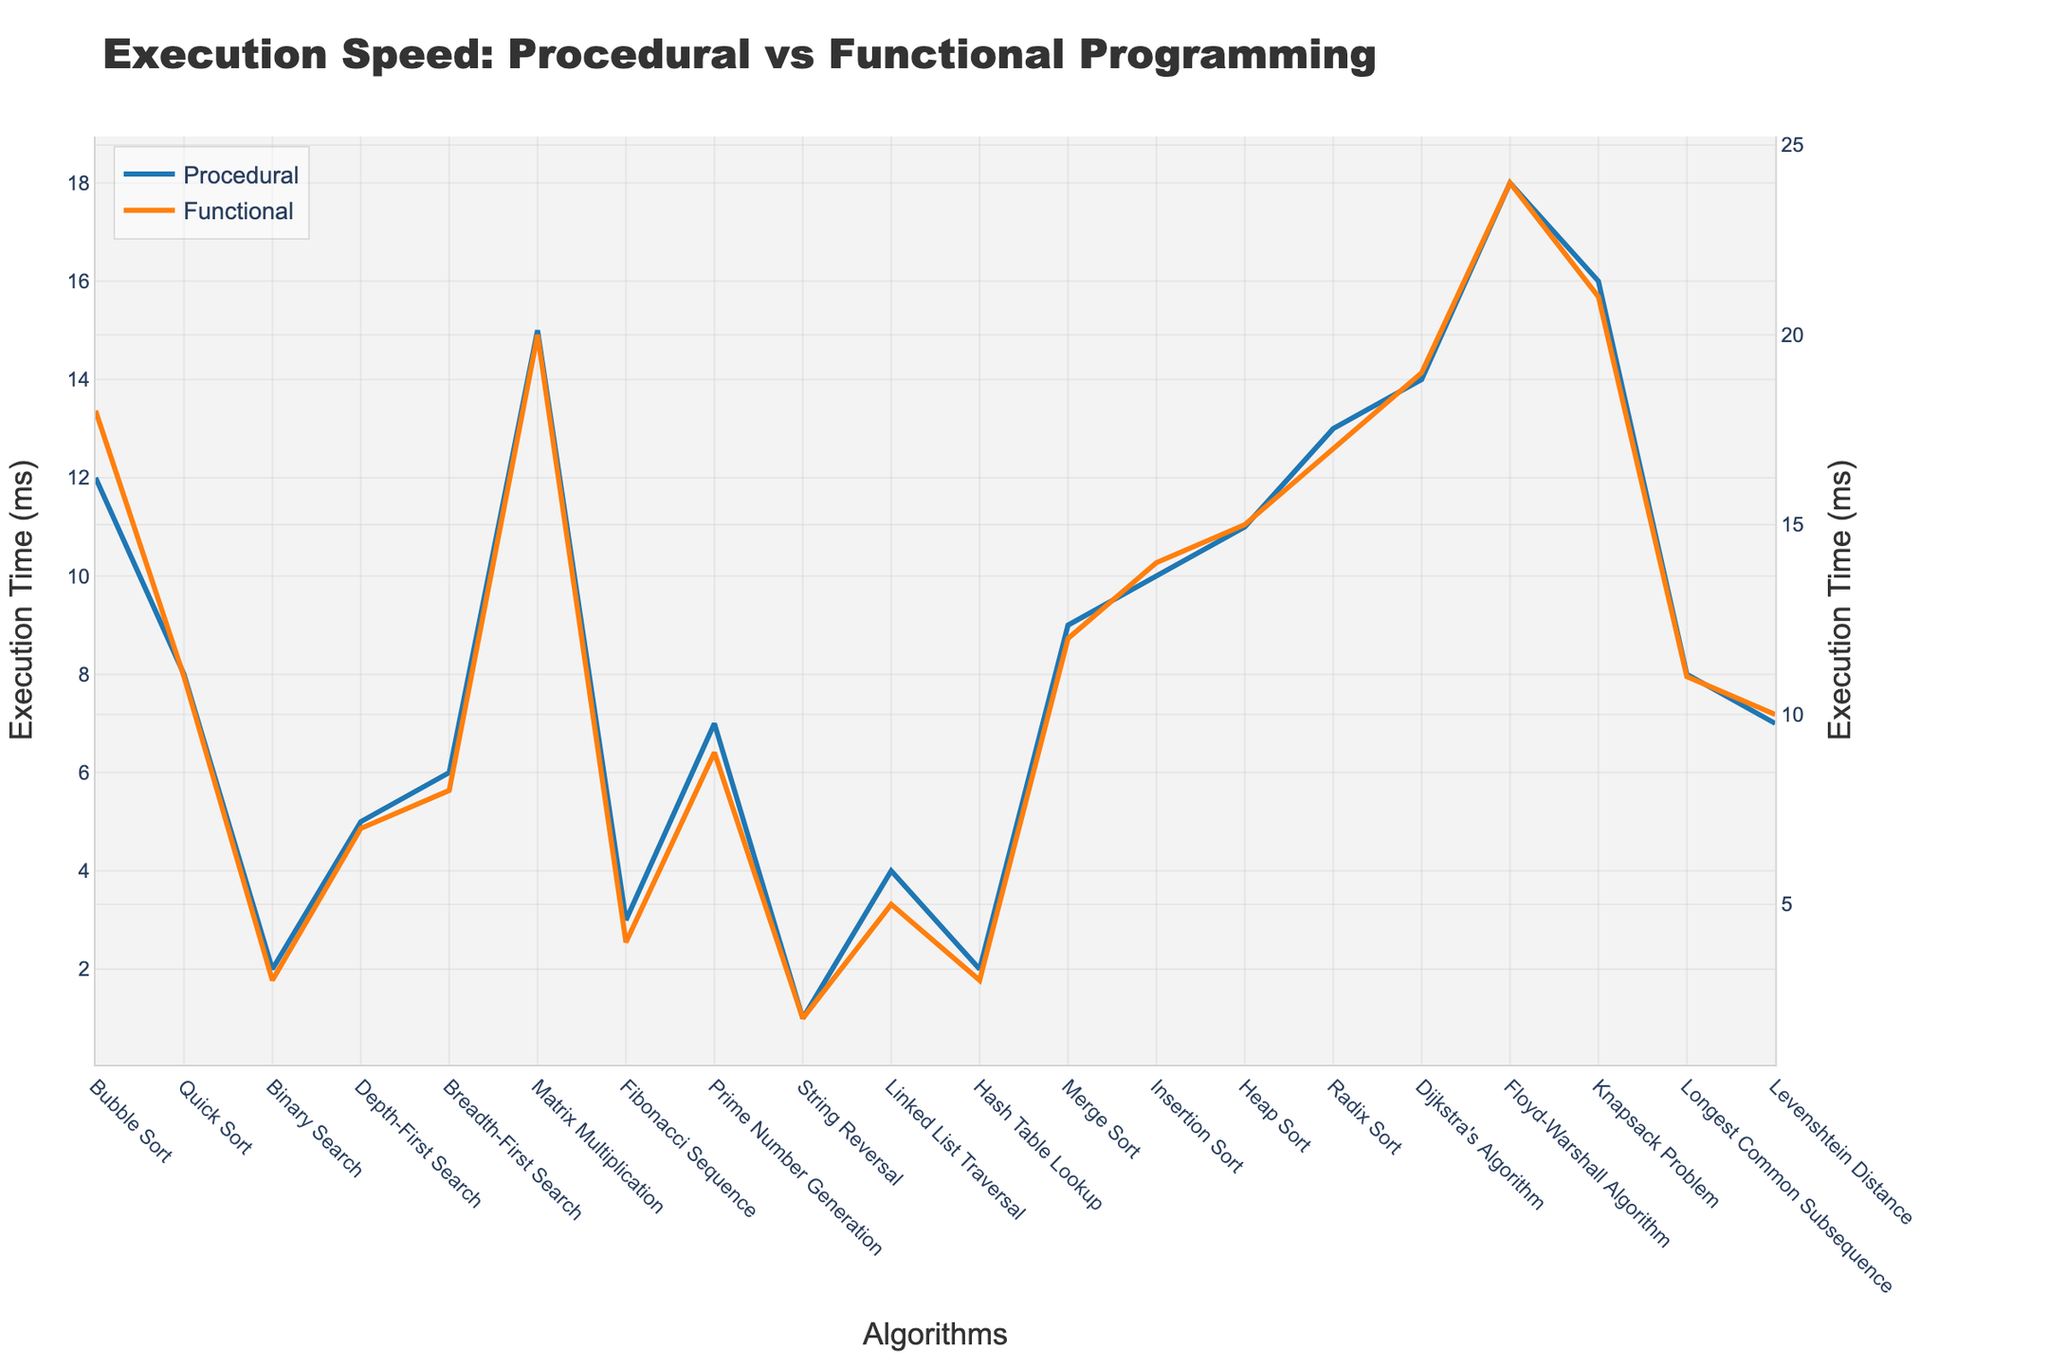What is the difference in execution time for the Bubble Sort algorithm between procedural and functional programming? The Bubble Sort algorithm has an execution time of 12 ms for procedural programming and 18 ms for functional programming. The difference is calculated as 18 - 12 = 6 ms.
Answer: 6 ms For which algorithm is the execution time difference between procedural and functional programming the smallest? The Binary Search algorithm has execution times of 2 ms (procedural) and 3 ms (functional). The difference is 1 ms, which is the smallest difference compared to other algorithms.
Answer: Binary Search Which algorithm has the highest execution time in functional programming? Among the listed algorithms, the Floyd-Warshall algorithm has the highest execution time of 24 ms in functional programming.
Answer: Floyd-Warshall Algorithm By how much does procedural programming outperform functional programming in terms of execution speed for the Matrix Multiplication algorithm? The Matrix Multiplication algorithm has execution times of 15 ms (procedural) and 20 ms (functional). The difference is calculated as 20 - 15 = 5 ms. Procedural programming is faster by 5 ms.
Answer: 5 ms What is the average execution time for algorithms in procedural programming? Sum the execution times for all algorithms in procedural programming: 12 + 8 + 2 + 5 + 6 + 15 + 3 + 7 + 1 + 4 + 2 + 9 + 10 + 11 + 13 + 14 + 18 + 16 + 8 + 7 = 175 ms. There are 20 algorithms, so the average is 175 / 20 = 8.75 ms.
Answer: 8.75 ms Which algorithm has the smallest execution time for both procedural and functional programming, and what are those times? The String Reversal algorithm has the smallest execution time for both procedural (1 ms) and functional (2 ms) programming.
Answer: String Reversal (1 ms, 2 ms) For the Knapsack Problem algorithm, which programming paradigm is faster and what is the time difference? The execution time for the Knapsack Problem algorithm is 16 ms in procedural programming and 21 ms in functional programming. This makes procedural faster by 21 - 16 = 5 ms.
Answer: Procedural, 5 ms Considering the Depth-First Search and Breadth-First Search algorithms, which programming paradigm shows a smaller execution time difference, and what are the times? Depth-First Search has execution times of 5 ms (procedural) and 7 ms (functional), with a difference of 2 ms. Breadth-First Search has execution times of 6 ms (procedural) and 8 ms (functional), with a difference of 2 ms. Both algorithms have the same execution time difference.
Answer: Depth-First and Breadth-First, 2 ms What is the median execution time for functional programming across all algorithms? First, sort the functional execution times: 2, 3, 3, 4, 5, 7, 8, 8, 9, 10, 11, 11, 12, 14, 15, 17, 18, 19, 20, 21, 24. Since there are 20 values, the median is the average of the 10th and 11th values: (10 + 11) / 2 = 10.5 ms.
Answer: 10.5 ms 